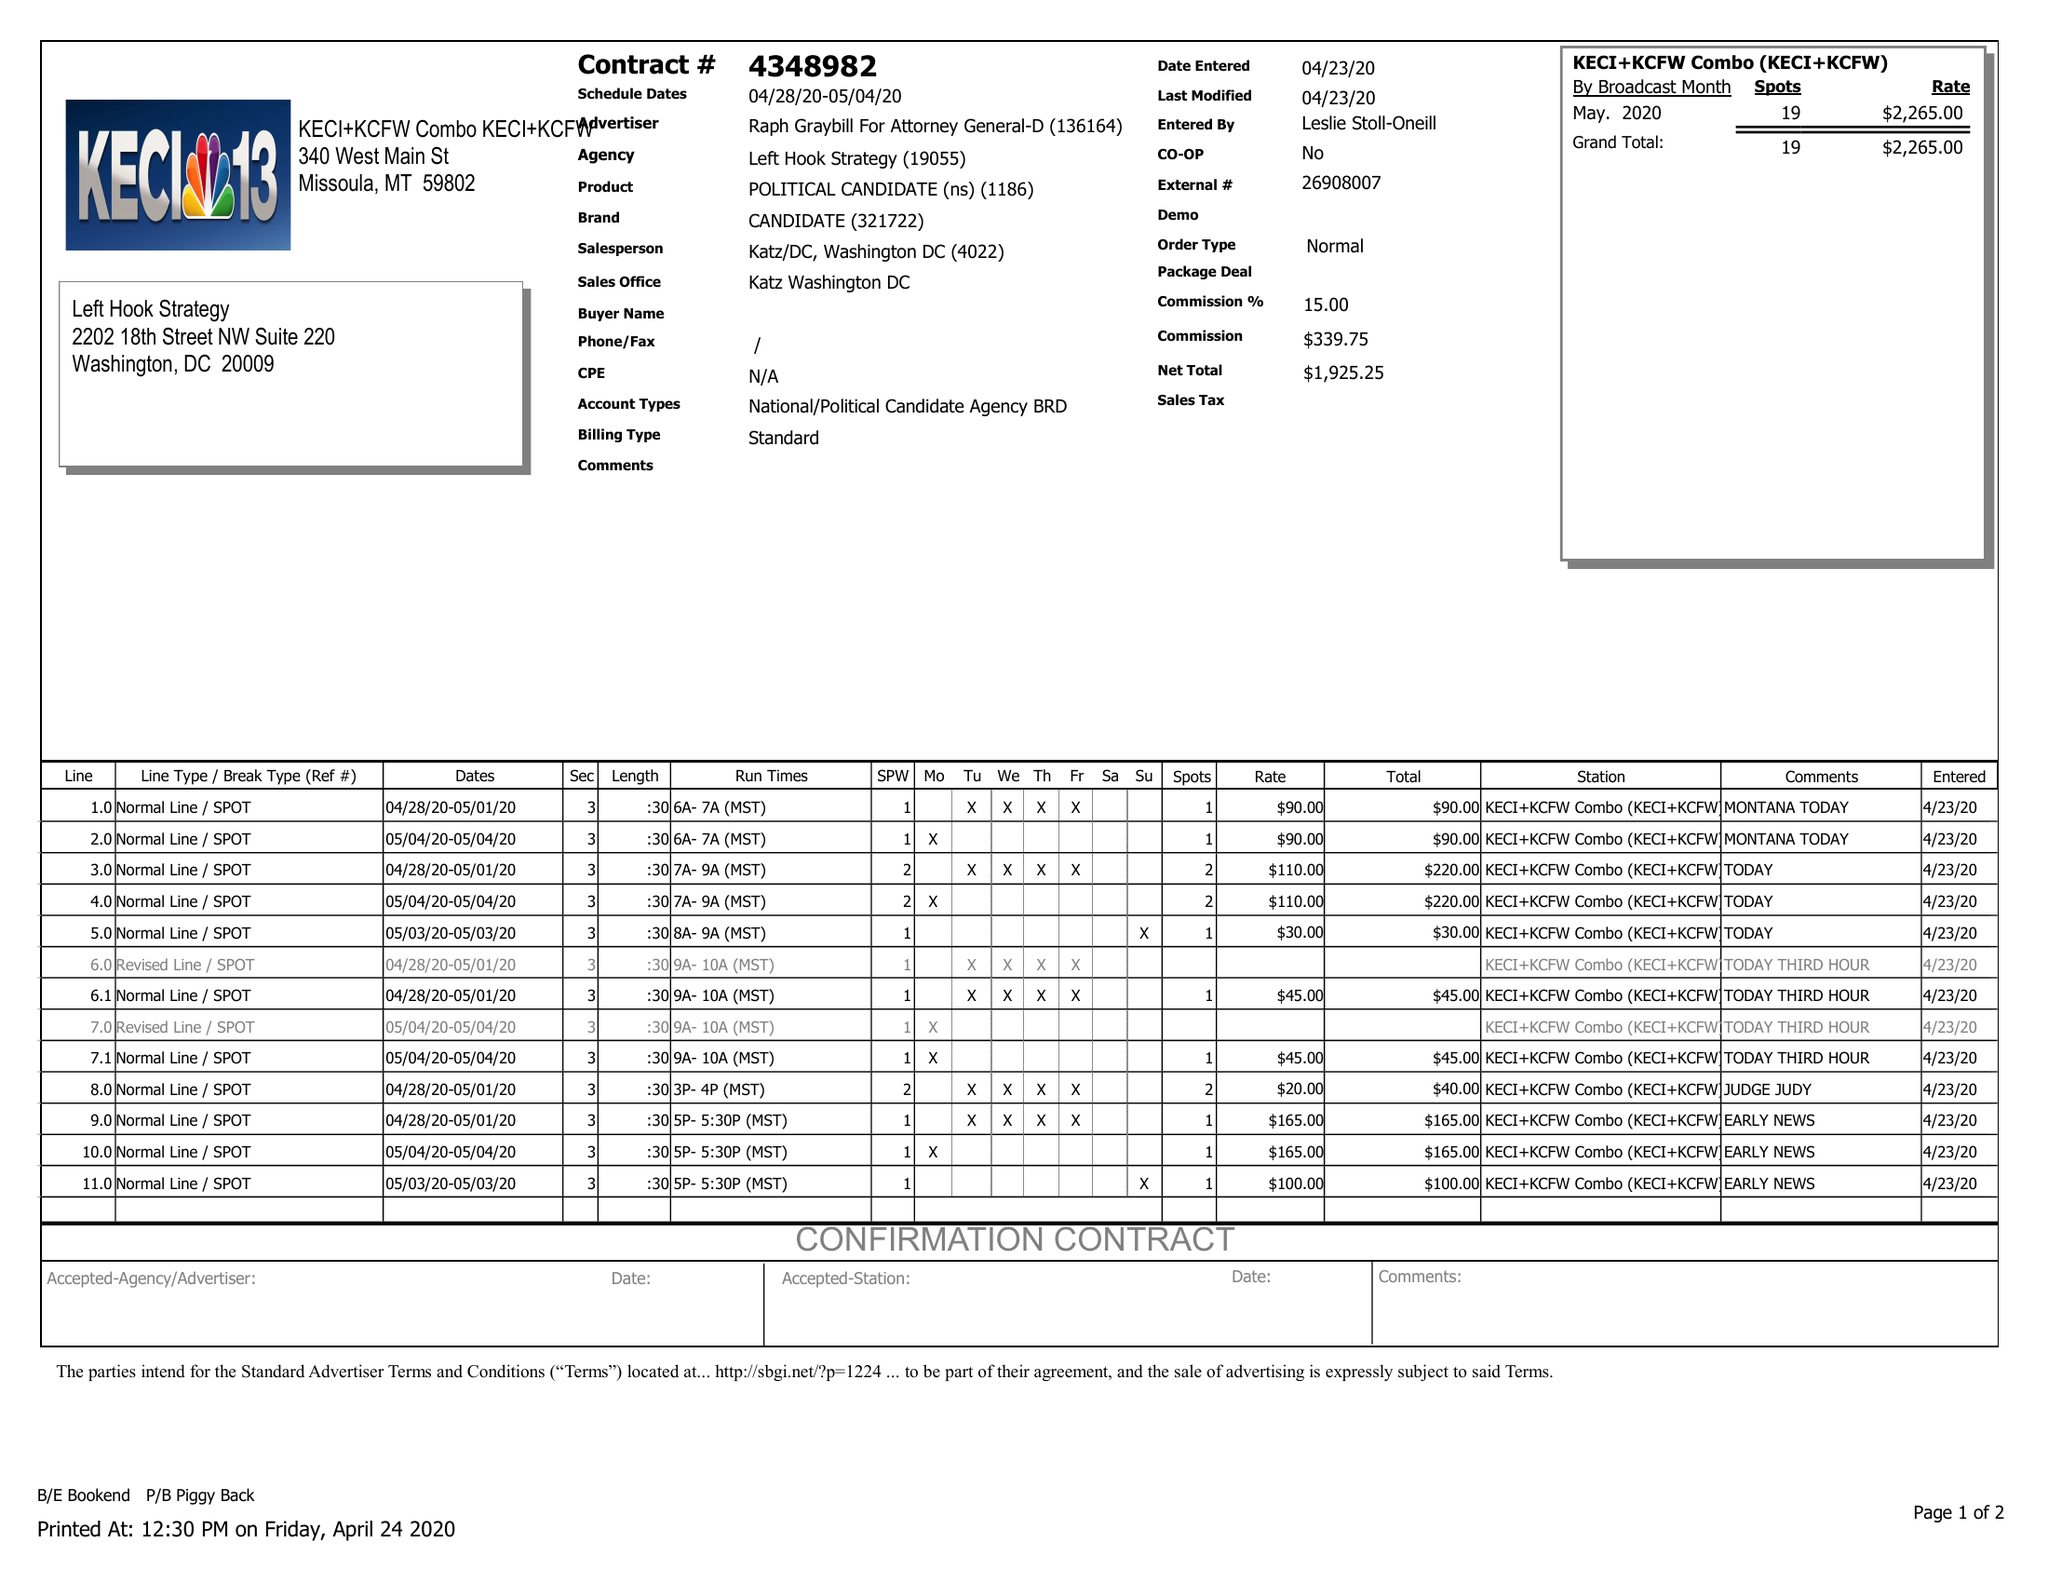What is the value for the flight_to?
Answer the question using a single word or phrase. 05/04/20 